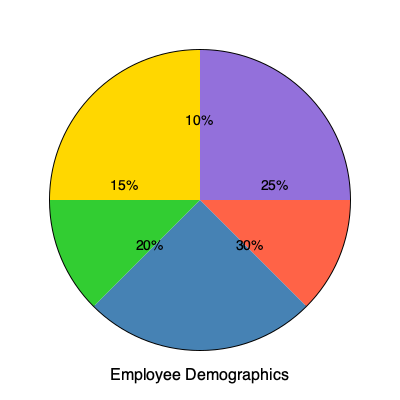Based on the pie chart of employee demographics, what percentage of employees fall into the two largest categories combined? To answer this question, we need to follow these steps:

1. Identify the two largest categories in the pie chart:
   - The largest slice is blue, representing 30% of employees.
   - The second-largest slice is red, representing 25% of employees.

2. Add the percentages of these two categories:
   $30\% + 25\% = 55\%$

This sum represents the percentage of employees in the two largest categories combined.

As a department supervisor working with the HR coordinator, understanding these demographics is crucial for effective employee management and ensuring compliance with diversity and inclusion policies.
Answer: 55% 